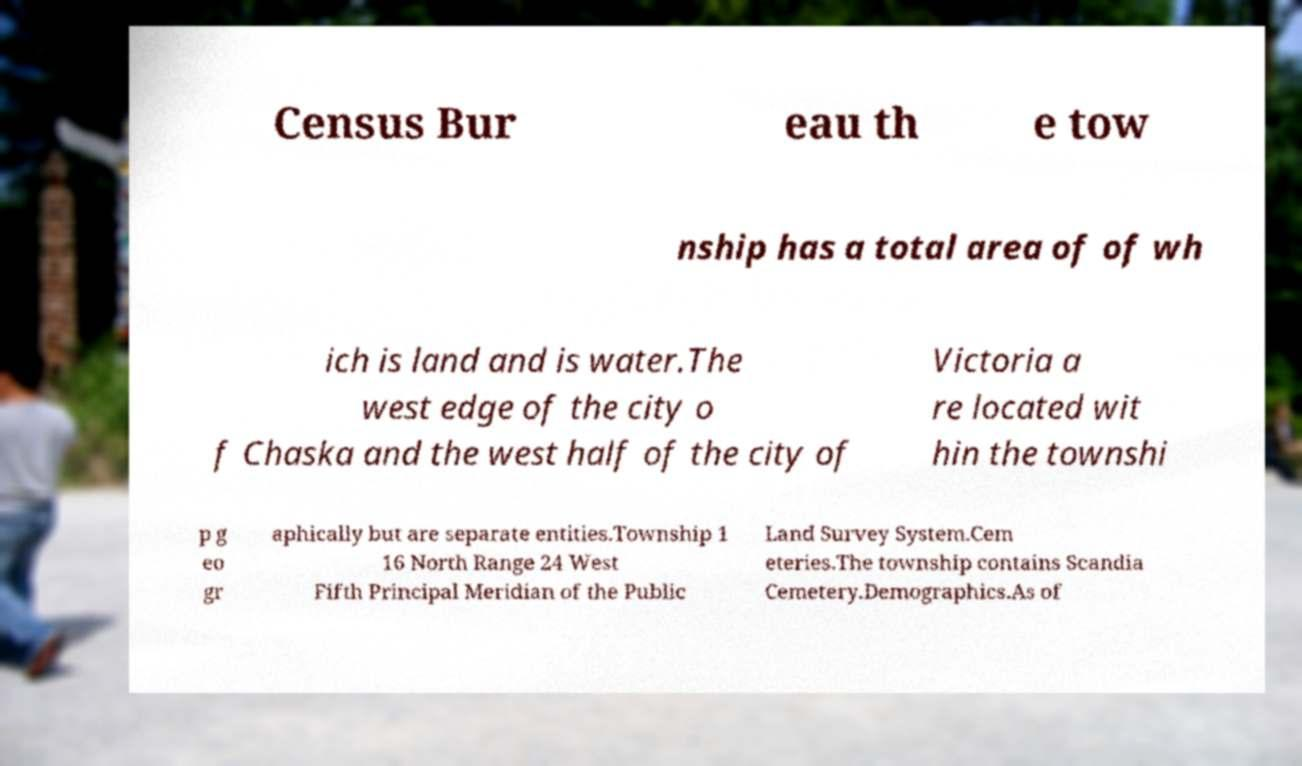Please read and relay the text visible in this image. What does it say? Census Bur eau th e tow nship has a total area of of wh ich is land and is water.The west edge of the city o f Chaska and the west half of the city of Victoria a re located wit hin the townshi p g eo gr aphically but are separate entities.Township 1 16 North Range 24 West Fifth Principal Meridian of the Public Land Survey System.Cem eteries.The township contains Scandia Cemetery.Demographics.As of 